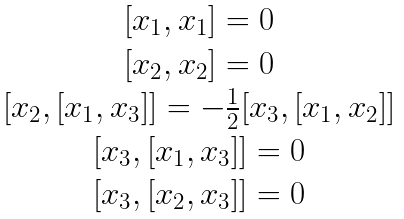Convert formula to latex. <formula><loc_0><loc_0><loc_500><loc_500>\begin{matrix} { { [ x _ { 1 } , x _ { 1 } ] } = 0 } \\ { { [ x _ { 2 } , x _ { 2 } ] } = 0 } \\ { { [ x _ { 2 } , [ x _ { 1 } , x _ { 3 } ] ] } = { { - \frac { 1 } { 2 } [ x _ { 3 } , [ x _ { 1 } , x _ { 2 } ] ] } } } \\ { { [ x _ { 3 } , [ x _ { 1 } , x _ { 3 } ] ] } = 0 } \\ { { [ x _ { 3 } , [ x _ { 2 } , x _ { 3 } ] ] } = 0 } \end{matrix}</formula> 